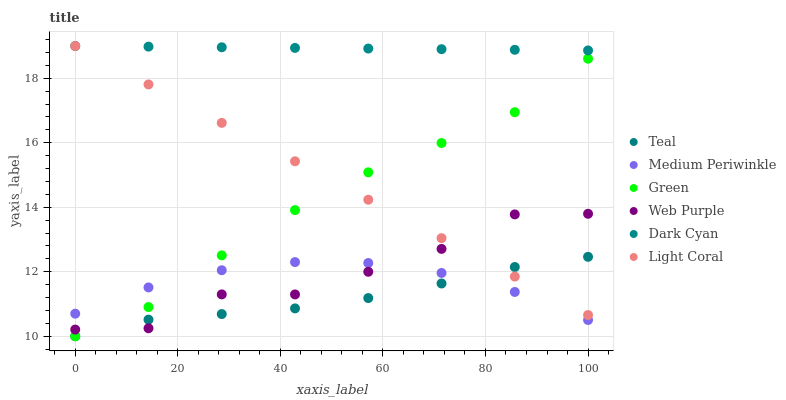Does Teal have the minimum area under the curve?
Answer yes or no. Yes. Does Dark Cyan have the maximum area under the curve?
Answer yes or no. Yes. Does Light Coral have the minimum area under the curve?
Answer yes or no. No. Does Light Coral have the maximum area under the curve?
Answer yes or no. No. Is Light Coral the smoothest?
Answer yes or no. Yes. Is Web Purple the roughest?
Answer yes or no. Yes. Is Web Purple the smoothest?
Answer yes or no. No. Is Light Coral the roughest?
Answer yes or no. No. Does Green have the lowest value?
Answer yes or no. Yes. Does Light Coral have the lowest value?
Answer yes or no. No. Does Dark Cyan have the highest value?
Answer yes or no. Yes. Does Web Purple have the highest value?
Answer yes or no. No. Is Teal less than Dark Cyan?
Answer yes or no. Yes. Is Light Coral greater than Medium Periwinkle?
Answer yes or no. Yes. Does Light Coral intersect Teal?
Answer yes or no. Yes. Is Light Coral less than Teal?
Answer yes or no. No. Is Light Coral greater than Teal?
Answer yes or no. No. Does Teal intersect Dark Cyan?
Answer yes or no. No. 